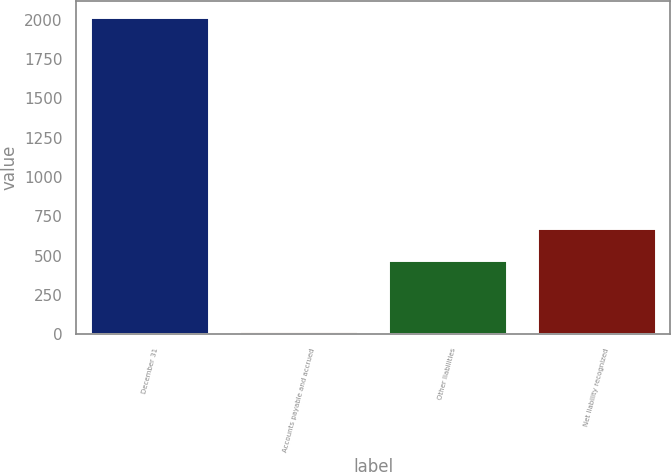<chart> <loc_0><loc_0><loc_500><loc_500><bar_chart><fcel>December 31<fcel>Accounts payable and accrued<fcel>Other liabilities<fcel>Net liability recognized<nl><fcel>2017<fcel>21<fcel>473<fcel>672.6<nl></chart> 